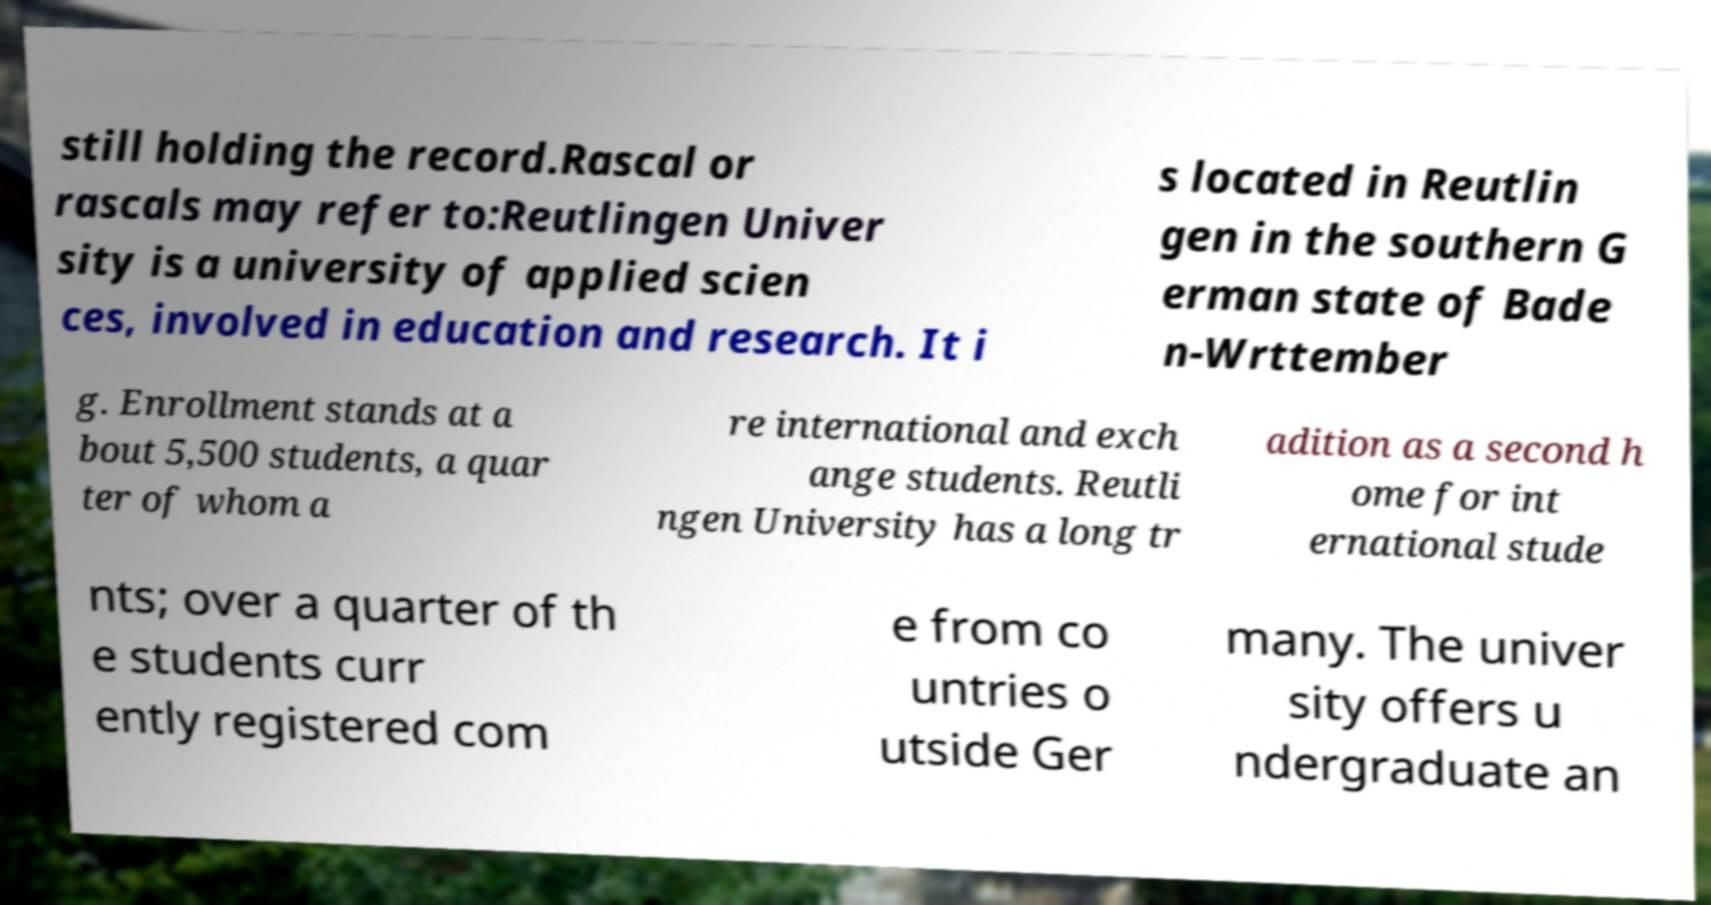I need the written content from this picture converted into text. Can you do that? still holding the record.Rascal or rascals may refer to:Reutlingen Univer sity is a university of applied scien ces, involved in education and research. It i s located in Reutlin gen in the southern G erman state of Bade n-Wrttember g. Enrollment stands at a bout 5,500 students, a quar ter of whom a re international and exch ange students. Reutli ngen University has a long tr adition as a second h ome for int ernational stude nts; over a quarter of th e students curr ently registered com e from co untries o utside Ger many. The univer sity offers u ndergraduate an 